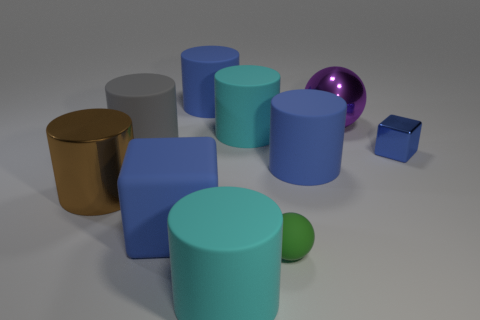Subtract 1 cylinders. How many cylinders are left? 5 Subtract all cyan cylinders. How many cylinders are left? 4 Subtract all large cyan cylinders. How many cylinders are left? 4 Subtract all blue cylinders. Subtract all yellow blocks. How many cylinders are left? 4 Subtract all cubes. How many objects are left? 8 Add 7 small gray cylinders. How many small gray cylinders exist? 7 Subtract 0 blue balls. How many objects are left? 10 Subtract all small objects. Subtract all blue matte things. How many objects are left? 5 Add 5 matte cylinders. How many matte cylinders are left? 10 